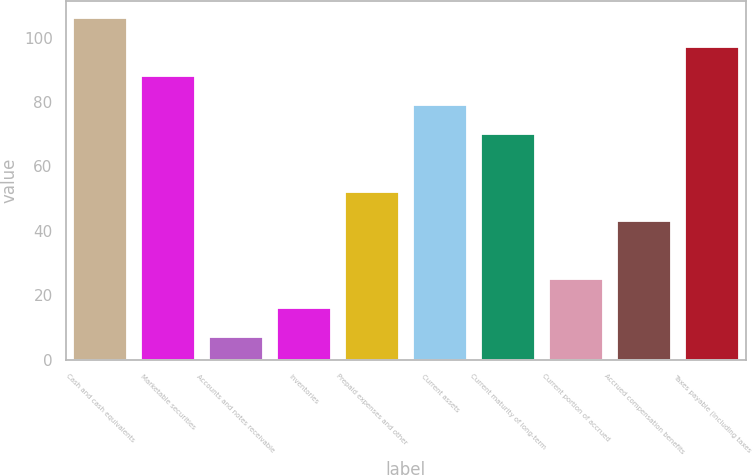Convert chart. <chart><loc_0><loc_0><loc_500><loc_500><bar_chart><fcel>Cash and cash equivalents<fcel>Marketable securities<fcel>Accounts and notes receivable<fcel>Inventories<fcel>Prepaid expenses and other<fcel>Current assets<fcel>Current maturity of long-term<fcel>Current portion of accrued<fcel>Accrued compensation benefits<fcel>Taxes payable (including taxes<nl><fcel>106<fcel>88<fcel>7<fcel>16<fcel>52<fcel>79<fcel>70<fcel>25<fcel>43<fcel>97<nl></chart> 